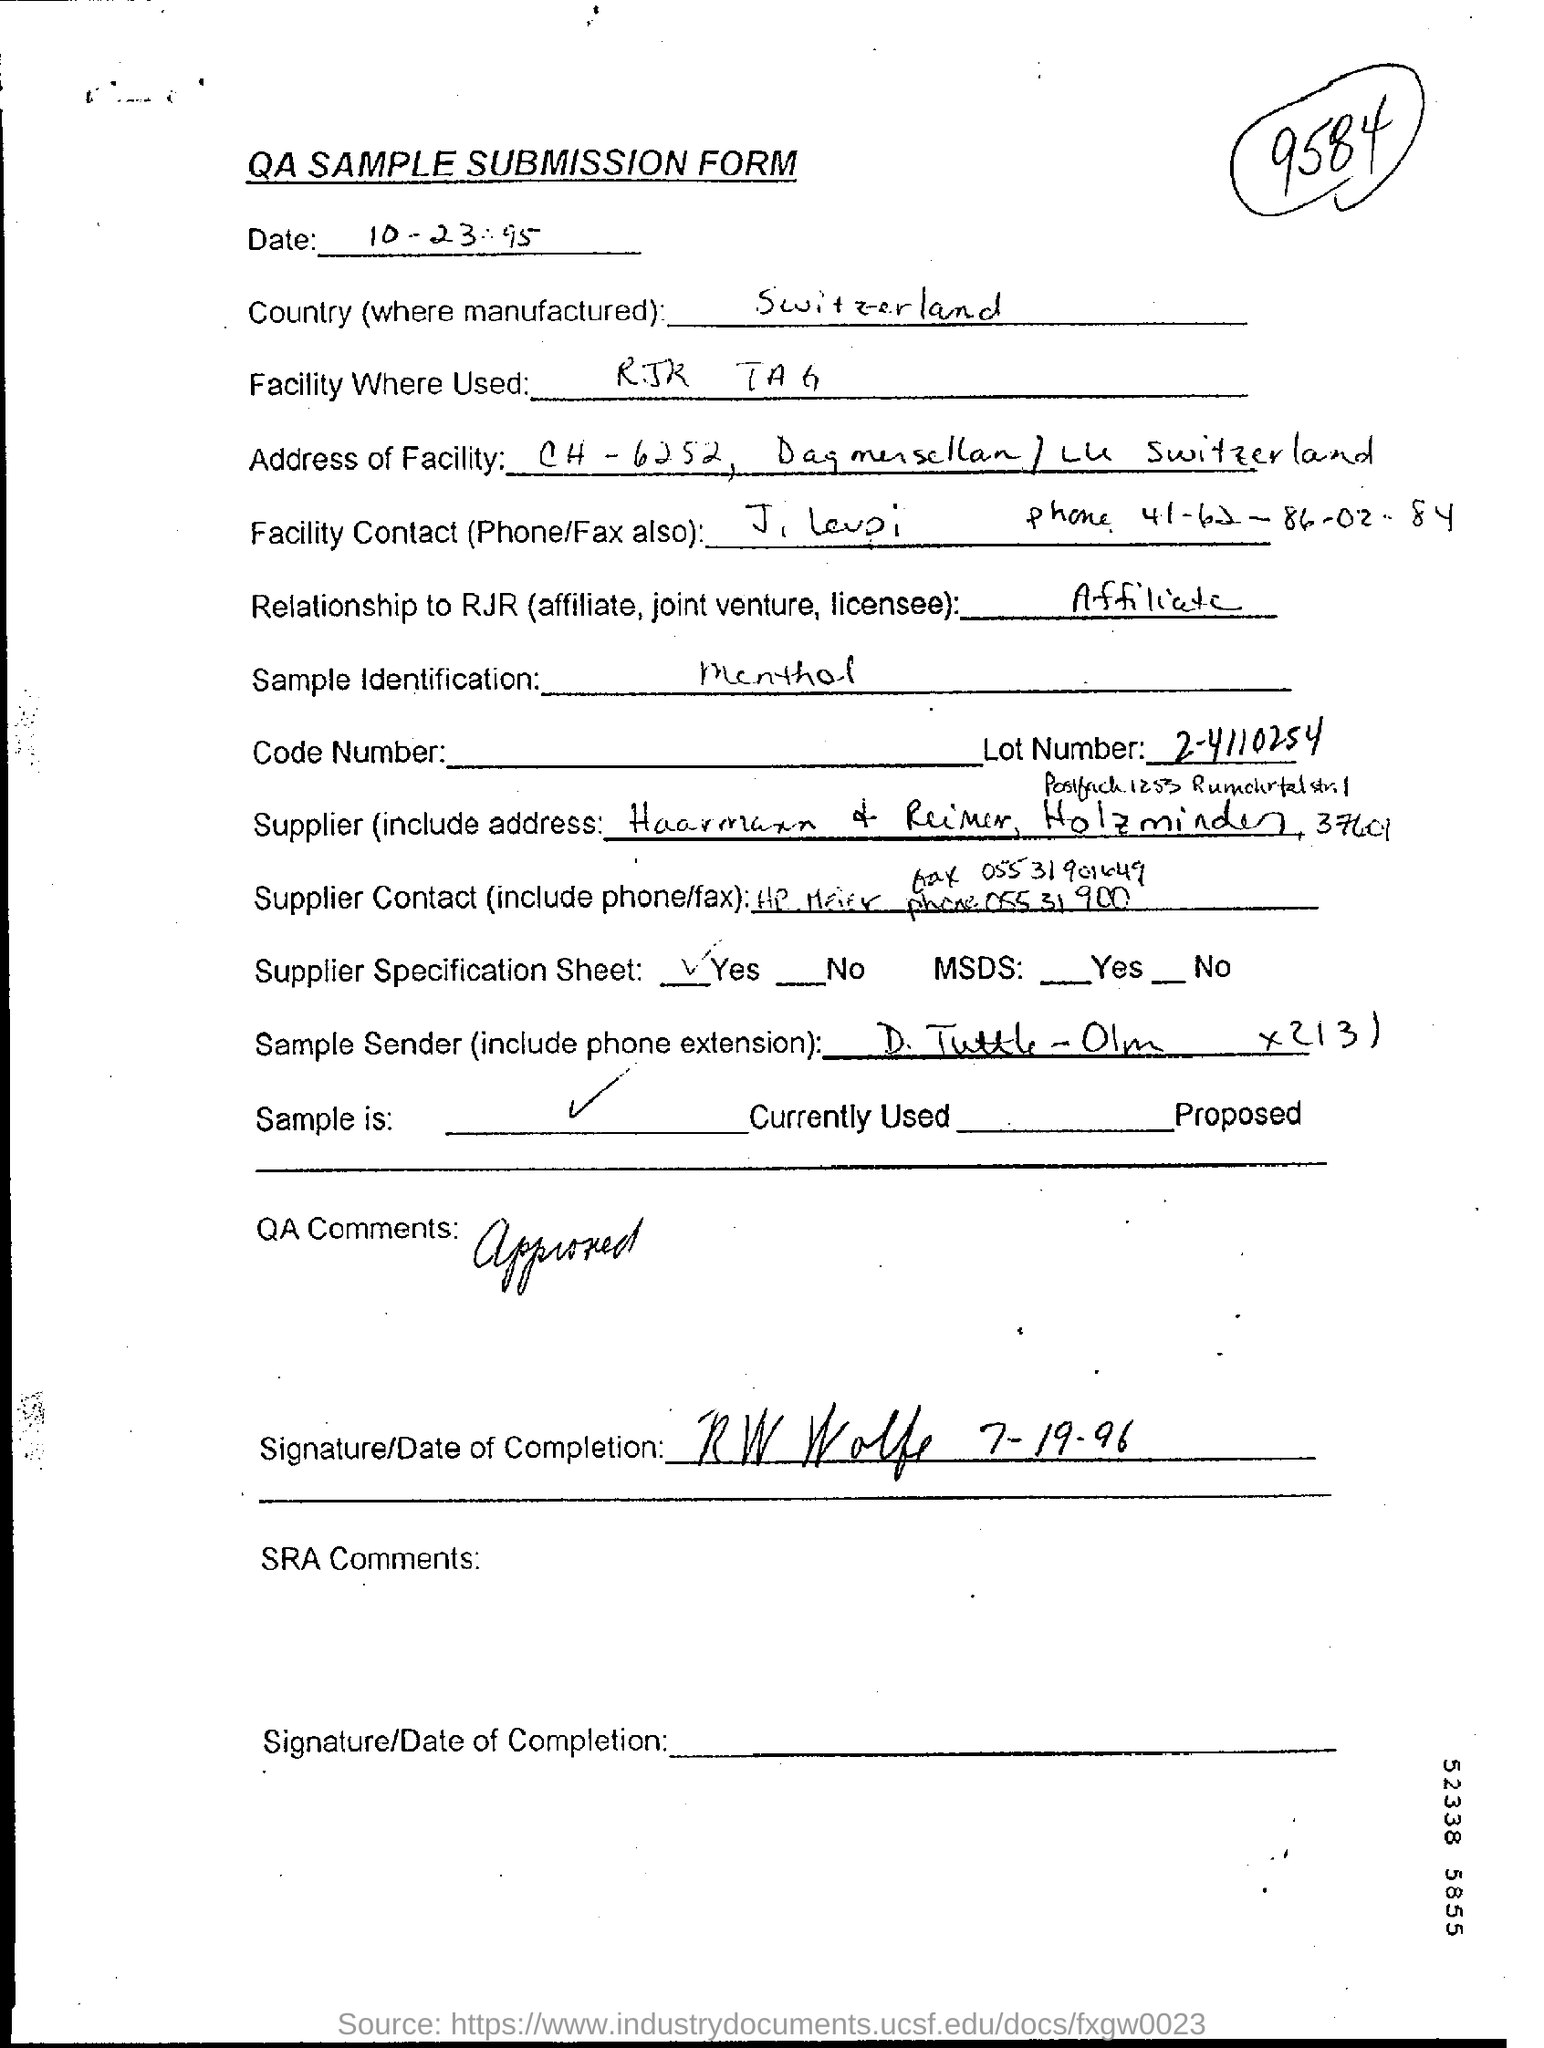Specify some key components in this picture. The lot number is 2-4110254... The RJR TAG facility is used. The document title is "QA Sample Submission Form. The country of Switzerland is mentioned. What is the relationship to RJR? I am an affiliate. 